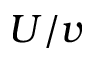Convert formula to latex. <formula><loc_0><loc_0><loc_500><loc_500>U / v</formula> 